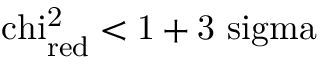Convert formula to latex. <formula><loc_0><loc_0><loc_500><loc_500>\ c h i _ { r e d } ^ { 2 } < 1 + 3 \ s i g m a</formula> 